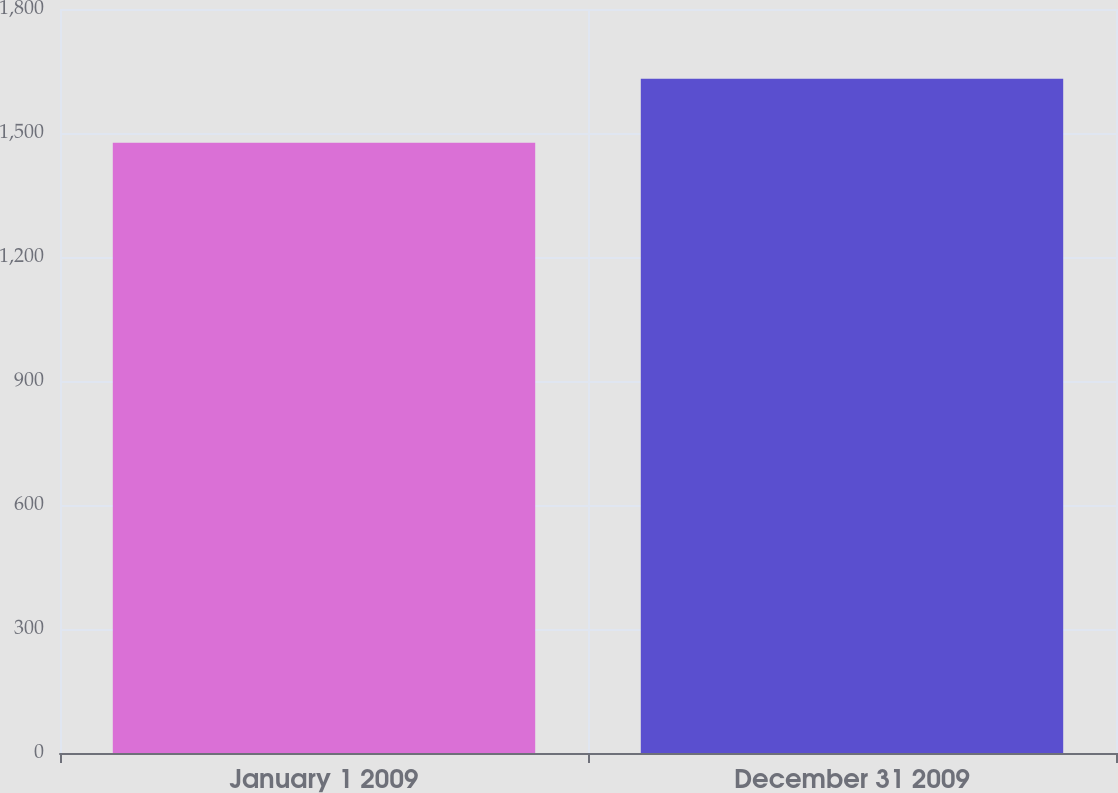Convert chart. <chart><loc_0><loc_0><loc_500><loc_500><bar_chart><fcel>January 1 2009<fcel>December 31 2009<nl><fcel>1476.3<fcel>1631.4<nl></chart> 